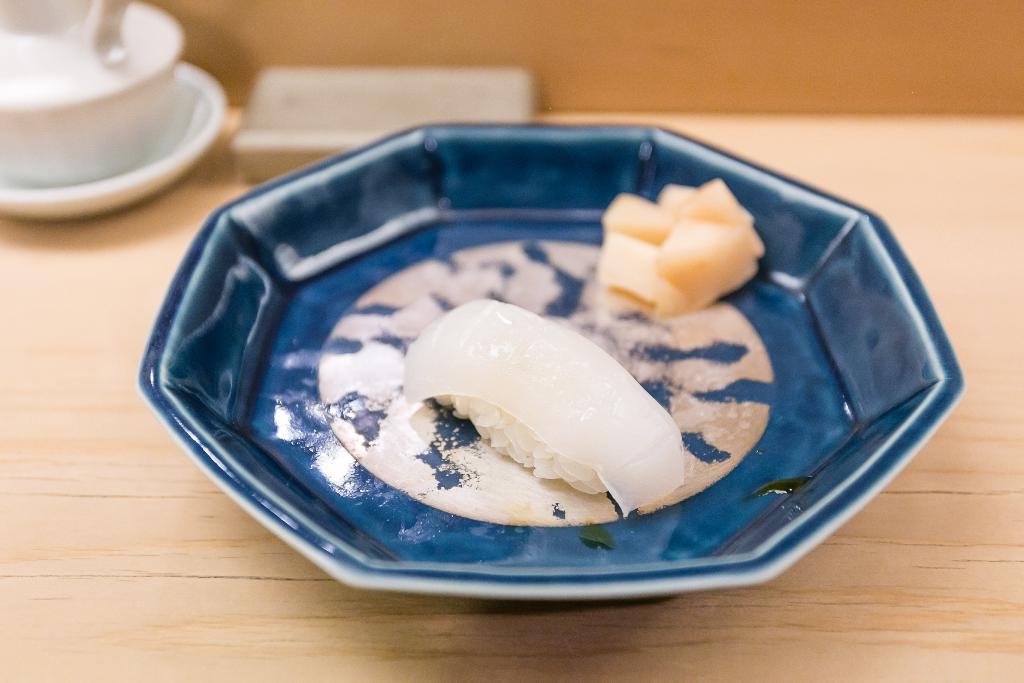What is on the plate that is visible in the image? There is food in a plate in the image. Where is the plate located in the image? The plate is placed on a table. What is the teapot used for in the image? The teapot is likely used for serving tea. What accompanies the teapot in the image? There is a saucer beside the teapot in the image. Can you see any snails crawling on the food in the image? No, there are no snails present in the image. 